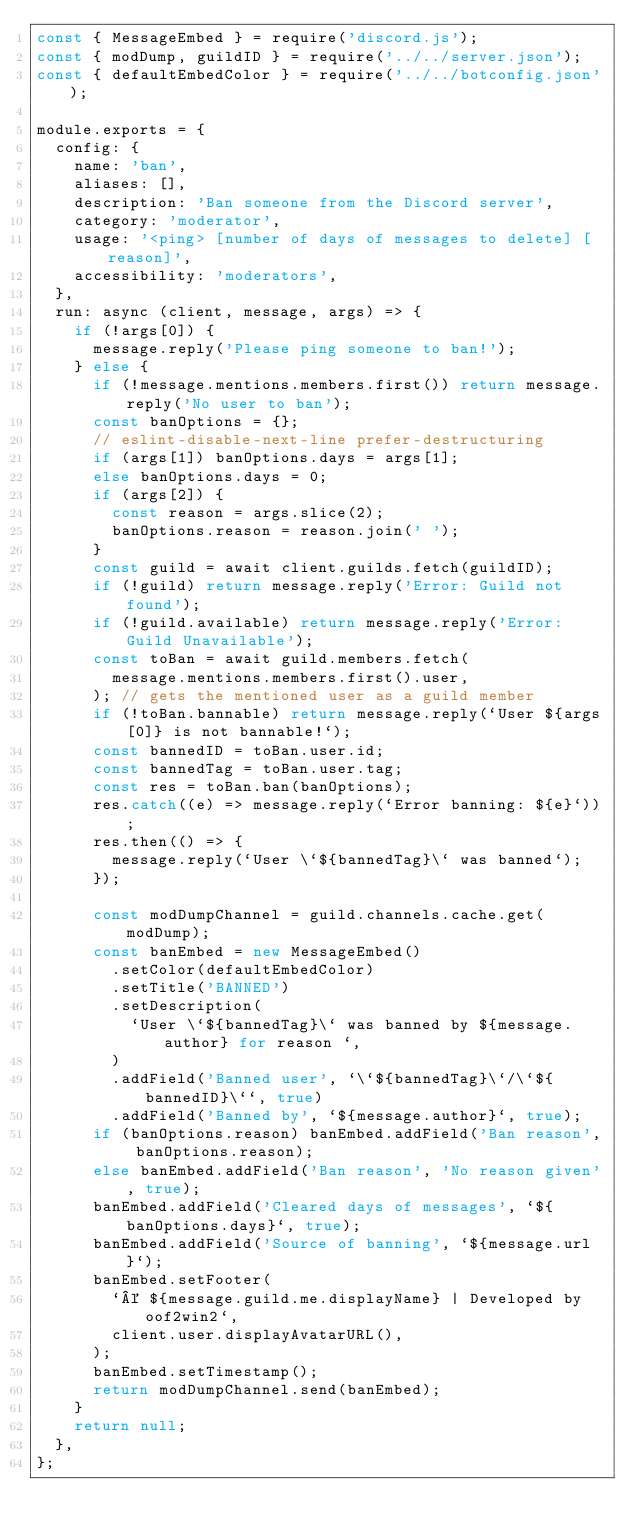Convert code to text. <code><loc_0><loc_0><loc_500><loc_500><_JavaScript_>const { MessageEmbed } = require('discord.js');
const { modDump, guildID } = require('../../server.json');
const { defaultEmbedColor } = require('../../botconfig.json');

module.exports = {
  config: {
    name: 'ban',
    aliases: [],
    description: 'Ban someone from the Discord server',
    category: 'moderator',
    usage: '<ping> [number of days of messages to delete] [reason]',
    accessibility: 'moderators',
  },
  run: async (client, message, args) => {
    if (!args[0]) {
      message.reply('Please ping someone to ban!');
    } else {
      if (!message.mentions.members.first()) return message.reply('No user to ban');
      const banOptions = {};
      // eslint-disable-next-line prefer-destructuring
      if (args[1]) banOptions.days = args[1];
      else banOptions.days = 0;
      if (args[2]) {
        const reason = args.slice(2);
        banOptions.reason = reason.join(' ');
      }
      const guild = await client.guilds.fetch(guildID);
      if (!guild) return message.reply('Error: Guild not found');
      if (!guild.available) return message.reply('Error: Guild Unavailable');
      const toBan = await guild.members.fetch(
        message.mentions.members.first().user,
      ); // gets the mentioned user as a guild member
      if (!toBan.bannable) return message.reply(`User ${args[0]} is not bannable!`);
      const bannedID = toBan.user.id;
      const bannedTag = toBan.user.tag;
      const res = toBan.ban(banOptions);
      res.catch((e) => message.reply(`Error banning: ${e}`));
      res.then(() => {
        message.reply(`User \`${bannedTag}\` was banned`);
      });

      const modDumpChannel = guild.channels.cache.get(modDump);
      const banEmbed = new MessageEmbed()
        .setColor(defaultEmbedColor)
        .setTitle('BANNED')
        .setDescription(
          `User \`${bannedTag}\` was banned by ${message.author} for reason `,
        )
        .addField('Banned user', `\`${bannedTag}\`/\`${bannedID}\``, true)
        .addField('Banned by', `${message.author}`, true);
      if (banOptions.reason) banEmbed.addField('Ban reason', banOptions.reason);
      else banEmbed.addField('Ban reason', 'No reason given', true);
      banEmbed.addField('Cleared days of messages', `${banOptions.days}`, true);
      banEmbed.addField('Source of banning', `${message.url}`);
      banEmbed.setFooter(
        `© ${message.guild.me.displayName} | Developed by oof2win2`,
        client.user.displayAvatarURL(),
      );
      banEmbed.setTimestamp();
      return modDumpChannel.send(banEmbed);
    }
    return null;
  },
};
</code> 